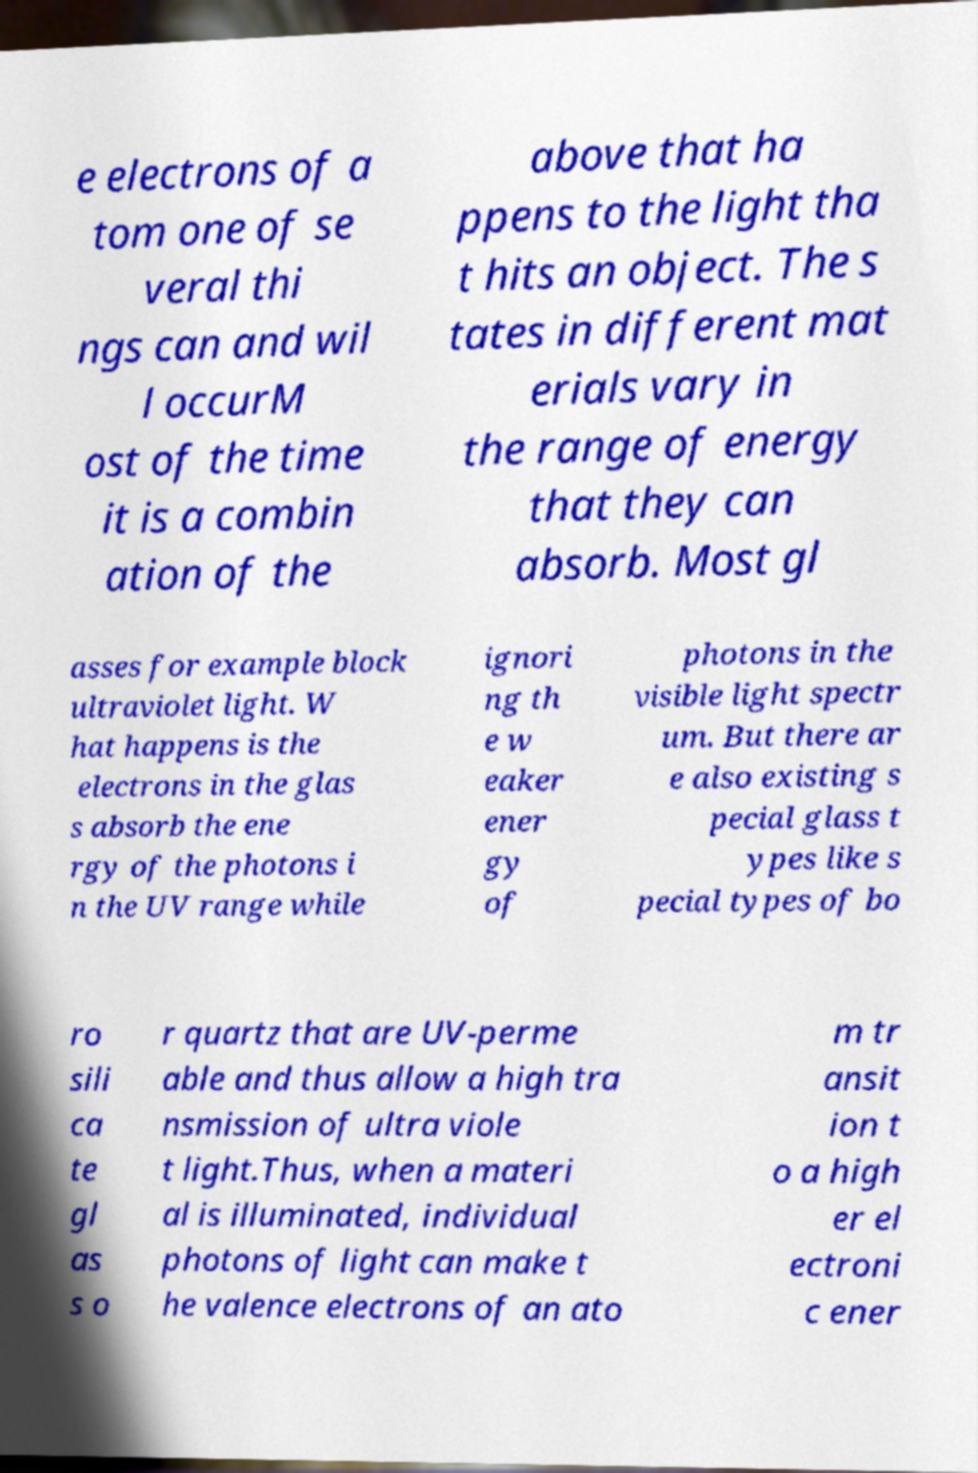Can you read and provide the text displayed in the image?This photo seems to have some interesting text. Can you extract and type it out for me? e electrons of a tom one of se veral thi ngs can and wil l occurM ost of the time it is a combin ation of the above that ha ppens to the light tha t hits an object. The s tates in different mat erials vary in the range of energy that they can absorb. Most gl asses for example block ultraviolet light. W hat happens is the electrons in the glas s absorb the ene rgy of the photons i n the UV range while ignori ng th e w eaker ener gy of photons in the visible light spectr um. But there ar e also existing s pecial glass t ypes like s pecial types of bo ro sili ca te gl as s o r quartz that are UV-perme able and thus allow a high tra nsmission of ultra viole t light.Thus, when a materi al is illuminated, individual photons of light can make t he valence electrons of an ato m tr ansit ion t o a high er el ectroni c ener 